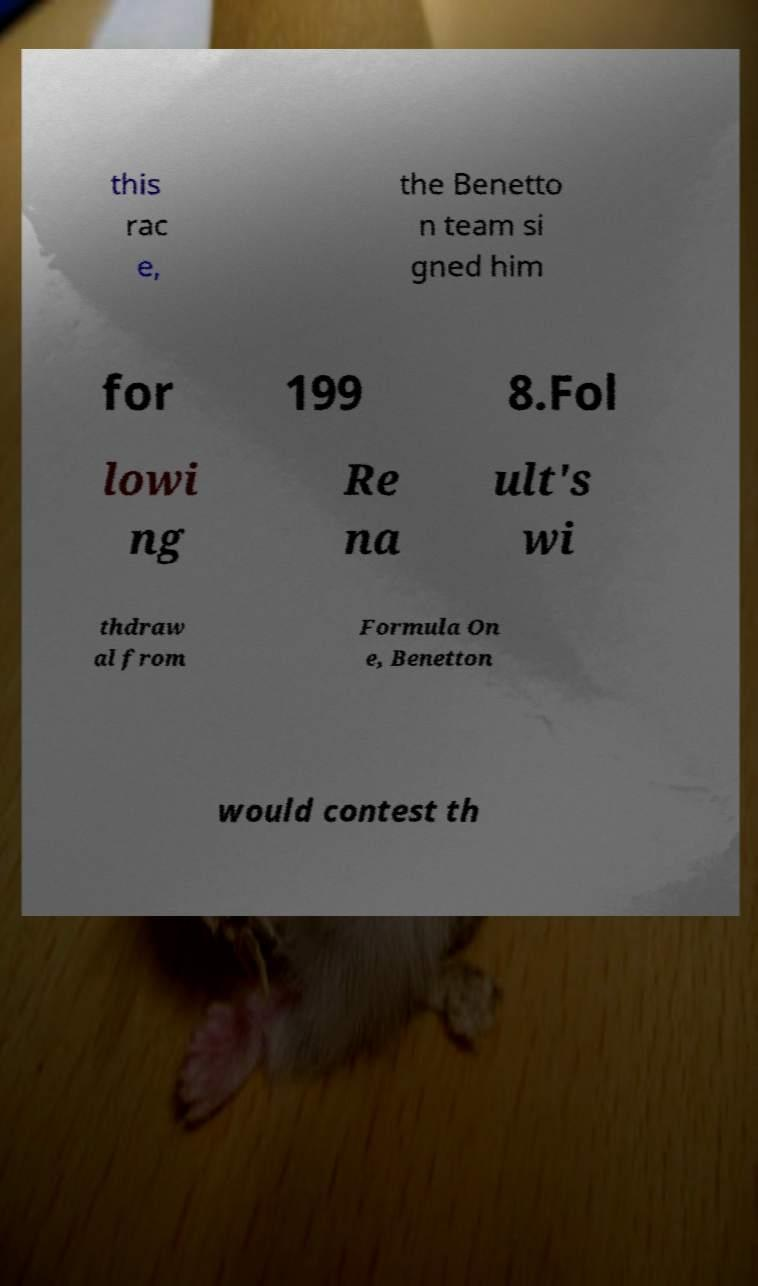Please read and relay the text visible in this image. What does it say? this rac e, the Benetto n team si gned him for 199 8.Fol lowi ng Re na ult's wi thdraw al from Formula On e, Benetton would contest th 